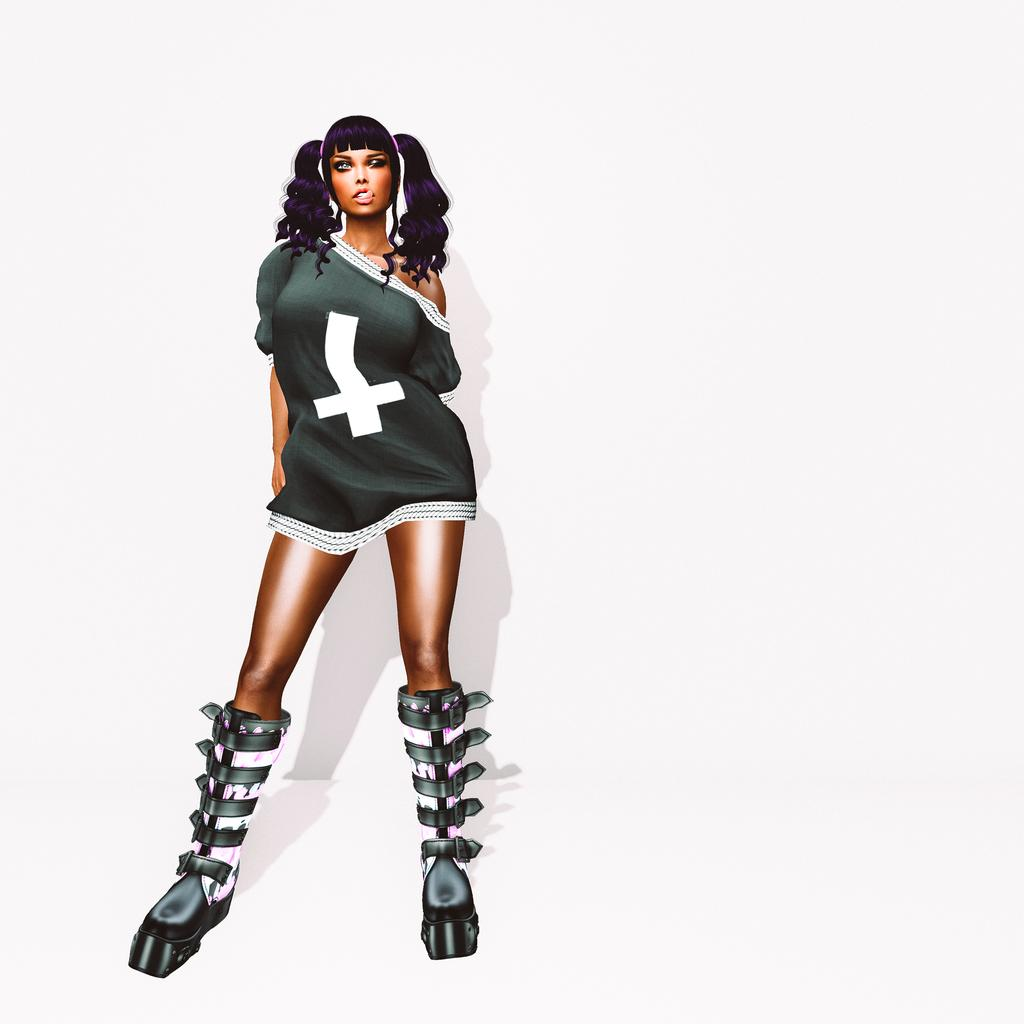What is the main subject of the image? There is a woman in the image. What is the woman doing in the image? The woman is standing and posing for a photo. How does the image appear? The image appears to be animated. What color is the background of the image? The background of the image is white in color. What type of shock can be seen on the woman's face in the image? There is no shock visible on the woman's face in the image. What type of writer is depicted in the image? There is no writer depicted in the image; it features a woman posing for a photo. 